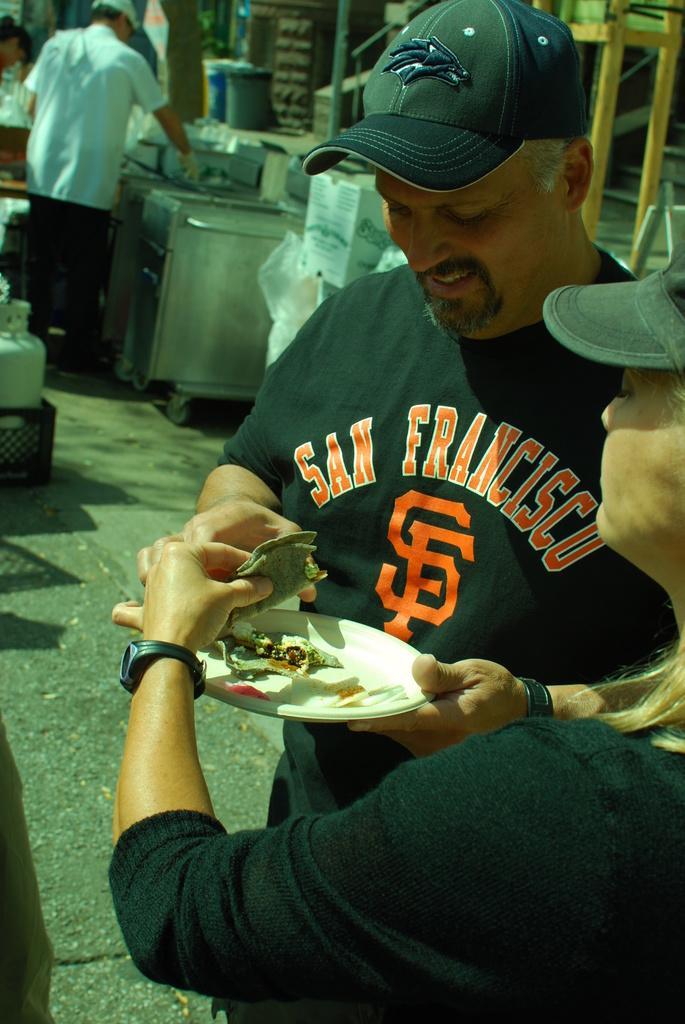Could you give a brief overview of what you see in this image? In the image there is a man and woman in black t-shirt and cap standing on the road eating street food, in the back there is a street food shop. 